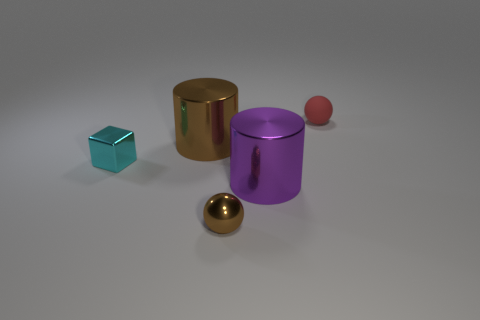Can you describe the texture and material of the objects? The objects appear to have a smooth, reflective surface, indicative of a metallic material, giving them a shiny finish that catches the light in different ways. Do the objects appear solid or hollow? The objects seem solid. However, without additional context or information, it's not possible to definitively conclude whether they are solid or hollow. 